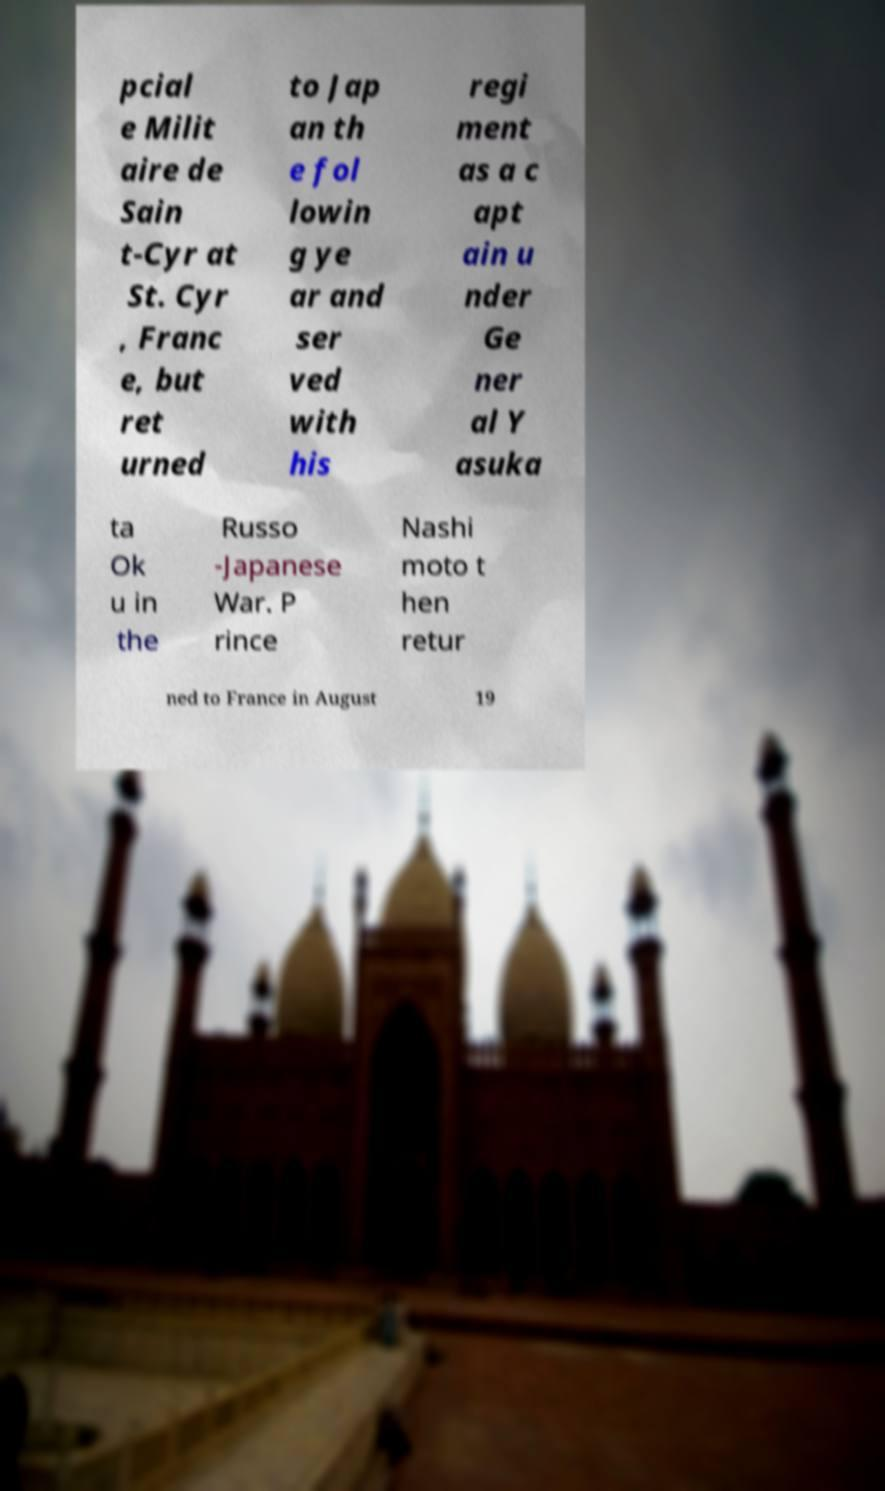Can you read and provide the text displayed in the image?This photo seems to have some interesting text. Can you extract and type it out for me? pcial e Milit aire de Sain t-Cyr at St. Cyr , Franc e, but ret urned to Jap an th e fol lowin g ye ar and ser ved with his regi ment as a c apt ain u nder Ge ner al Y asuka ta Ok u in the Russo -Japanese War. P rince Nashi moto t hen retur ned to France in August 19 